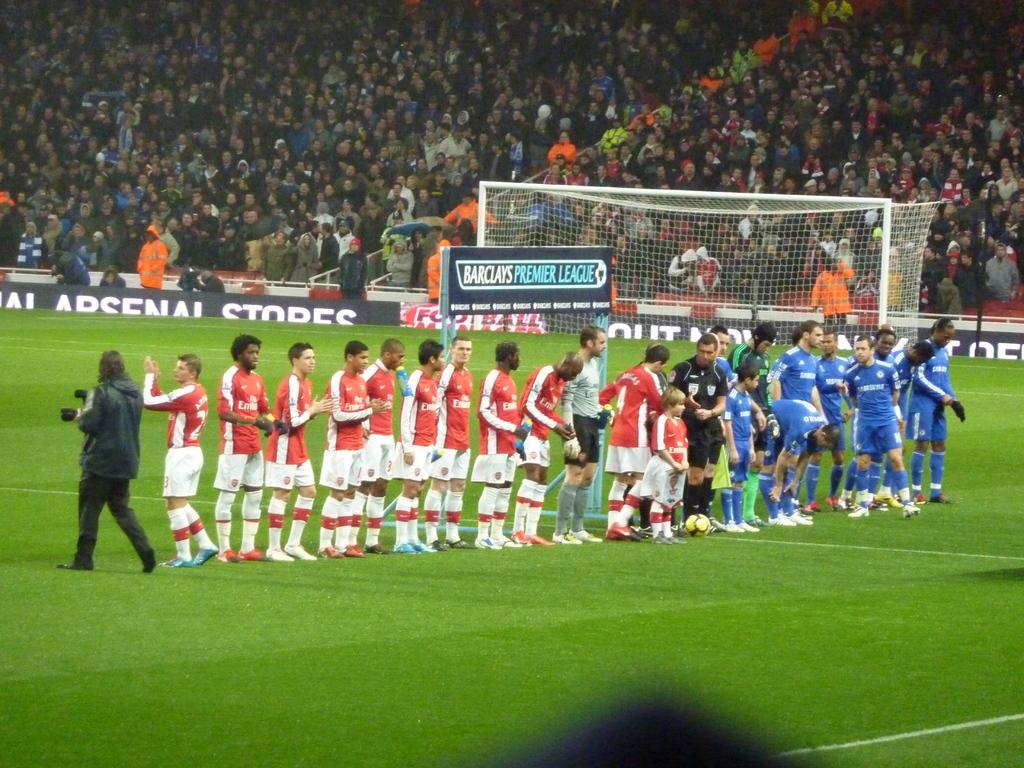What kind of league is it?
Make the answer very short. Football. 